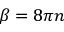Convert formula to latex. <formula><loc_0><loc_0><loc_500><loc_500>\beta = 8 \pi n</formula> 